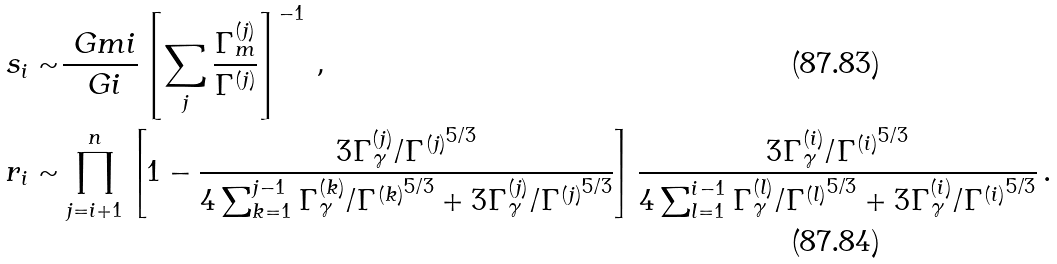<formula> <loc_0><loc_0><loc_500><loc_500>s _ { i } \sim & \frac { \ G m i } { \ G i } \left [ \sum _ { j } \frac { \Gamma _ { m } ^ { ( j ) } } { \Gamma ^ { ( j ) } } \right ] ^ { - 1 } \, , \\ r _ { i } \sim & \prod _ { j = i + 1 } ^ { n } \left [ 1 - \frac { 3 \Gamma _ { \gamma } ^ { ( j ) } / { \Gamma ^ { ( j ) } } ^ { 5 / 3 } } { 4 \sum _ { k = 1 } ^ { j - 1 } \Gamma _ { \gamma } ^ { ( k ) } / { \Gamma ^ { ( k ) } } ^ { 5 / 3 } + 3 \Gamma _ { \gamma } ^ { ( j ) } / { \Gamma ^ { ( j ) } } ^ { 5 / 3 } } \right ] \frac { 3 \Gamma _ { \gamma } ^ { ( i ) } / { \Gamma ^ { ( i ) } } ^ { 5 / 3 } } { 4 \sum _ { l = 1 } ^ { i - 1 } \Gamma _ { \gamma } ^ { ( l ) } / { \Gamma ^ { ( l ) } } ^ { 5 / 3 } + 3 \Gamma _ { \gamma } ^ { ( i ) } / { \Gamma ^ { ( i ) } } ^ { 5 / 3 } } \, .</formula> 